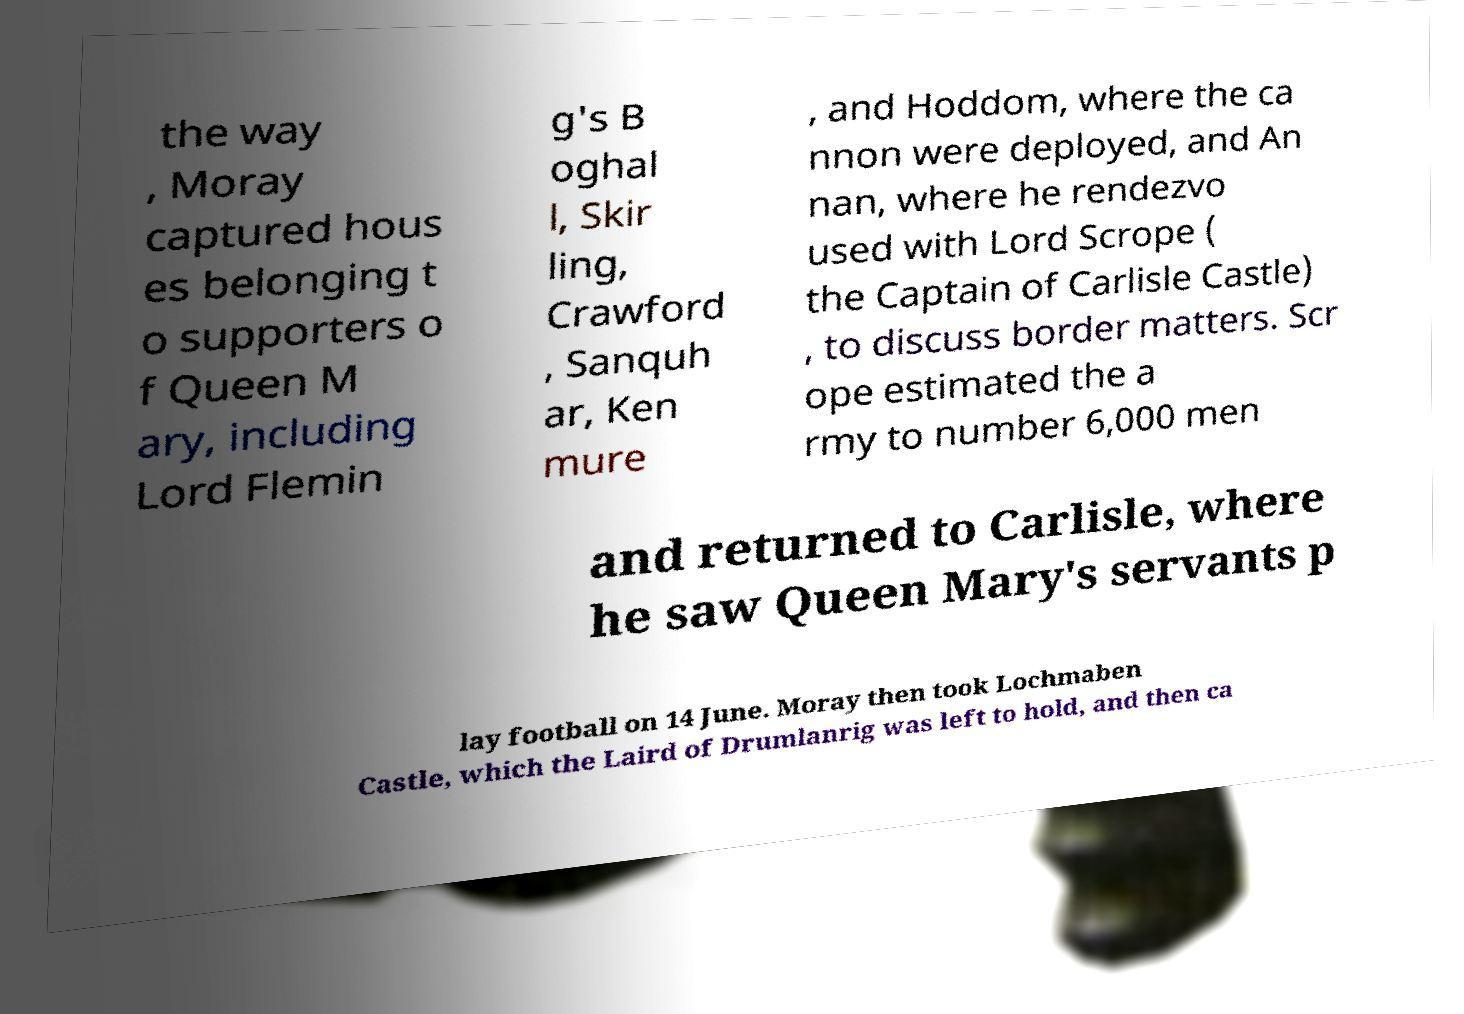Please read and relay the text visible in this image. What does it say? the way , Moray captured hous es belonging t o supporters o f Queen M ary, including Lord Flemin g's B oghal l, Skir ling, Crawford , Sanquh ar, Ken mure , and Hoddom, where the ca nnon were deployed, and An nan, where he rendezvo used with Lord Scrope ( the Captain of Carlisle Castle) , to discuss border matters. Scr ope estimated the a rmy to number 6,000 men and returned to Carlisle, where he saw Queen Mary's servants p lay football on 14 June. Moray then took Lochmaben Castle, which the Laird of Drumlanrig was left to hold, and then ca 